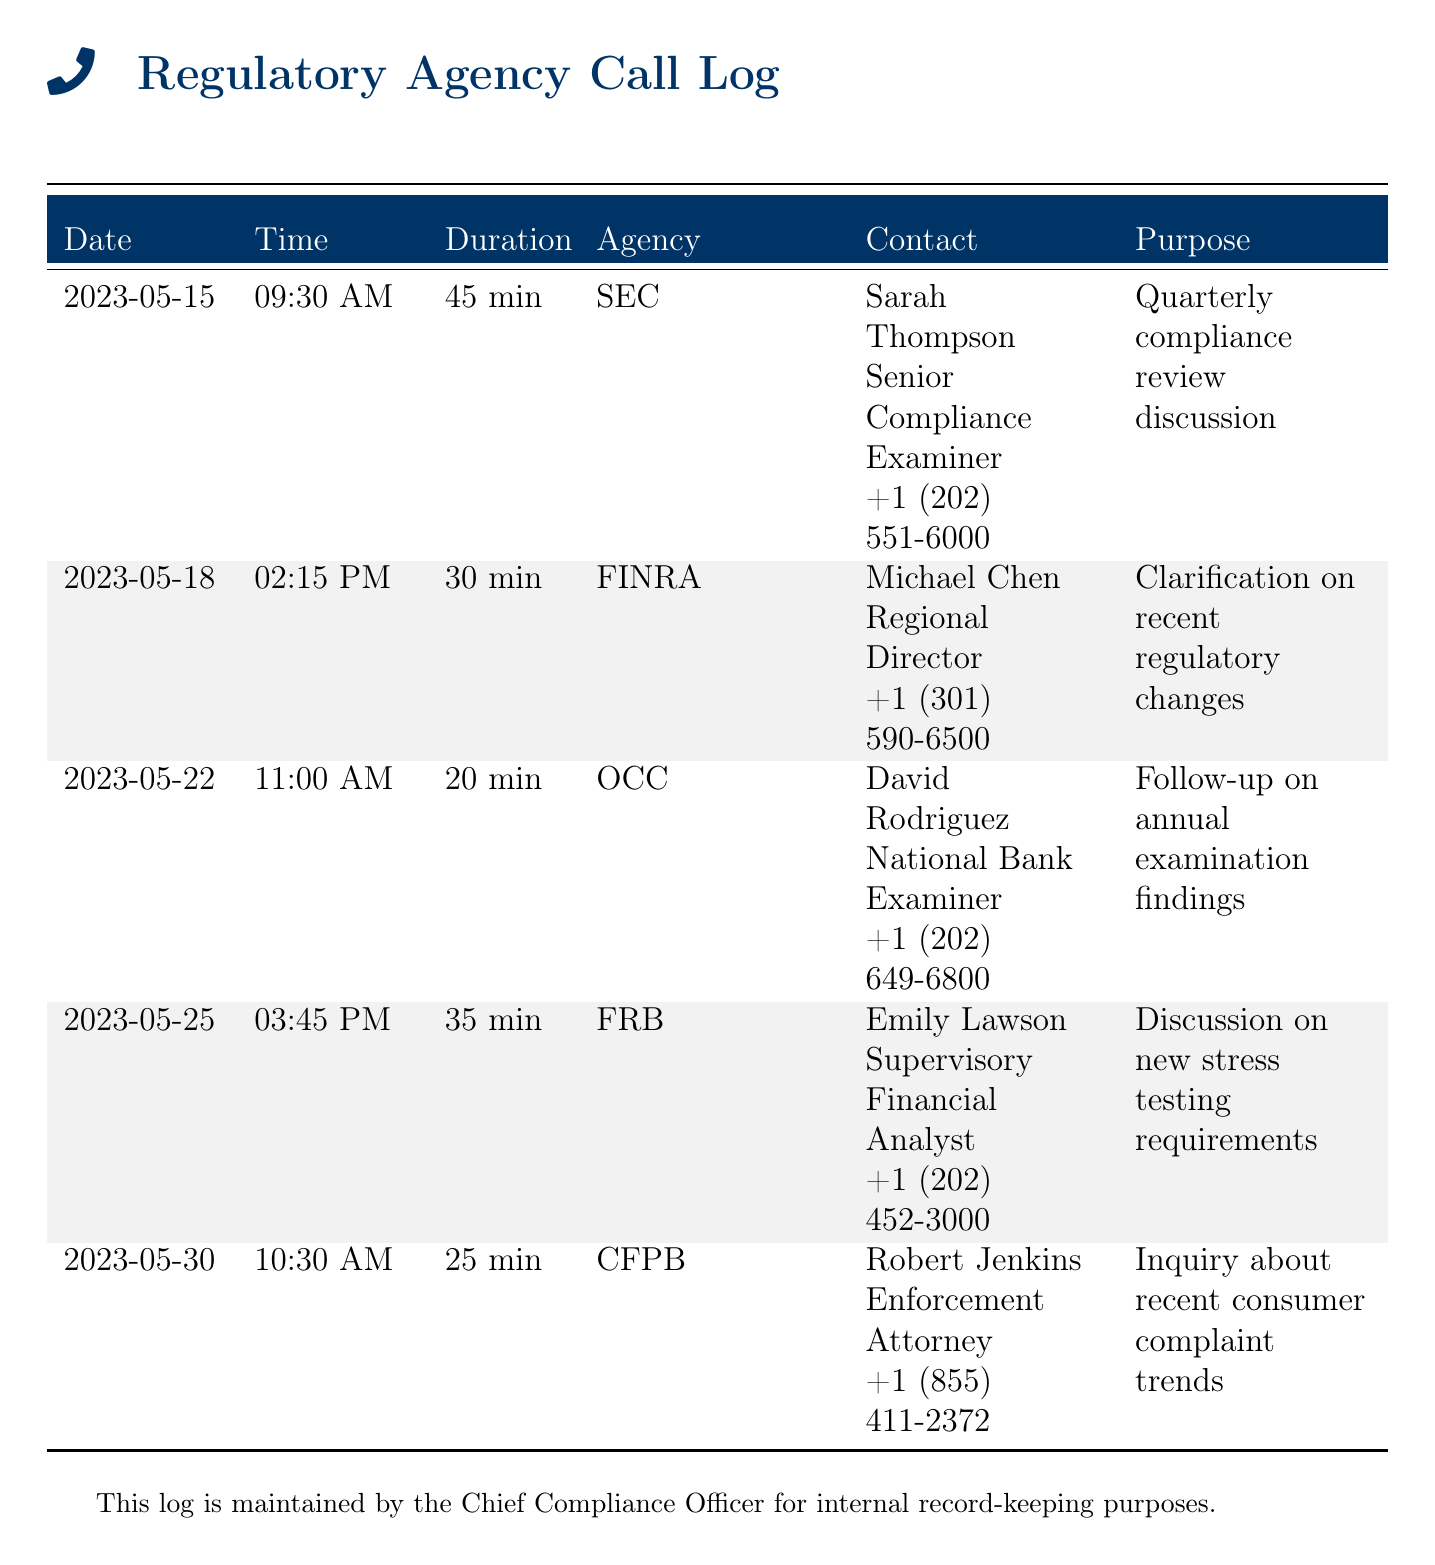What is the date of the first call? The first call in the log is dated May 15, 2023.
Answer: May 15, 2023 Who was the contact person for the SEC? The contact person for the SEC was Sarah Thompson, a Senior Compliance Examiner.
Answer: Sarah Thompson What was the duration of the call with FINRA? The duration of the call with FINRA was 30 minutes.
Answer: 30 min Which agency had a call on May 25, 2023? The call on May 25, 2023, was with the FRB.
Answer: FRB What was the purpose of the call with the CFPB? The purpose of the call with the CFPB was to inquire about recent consumer complaint trends.
Answer: Inquiry about recent consumer complaint trends Who was the contact for the OCC? The contact for the OCC was David Rodriguez, a National Bank Examiner.
Answer: David Rodriguez Which call had the longest duration? The longest call was with the SEC and lasted 45 minutes.
Answer: 45 min How many calls were recorded in this log? There were a total of five calls recorded in the log.
Answer: Five What time did the call with FINRA begin? The call with FINRA began at 2:15 PM.
Answer: 2:15 PM 